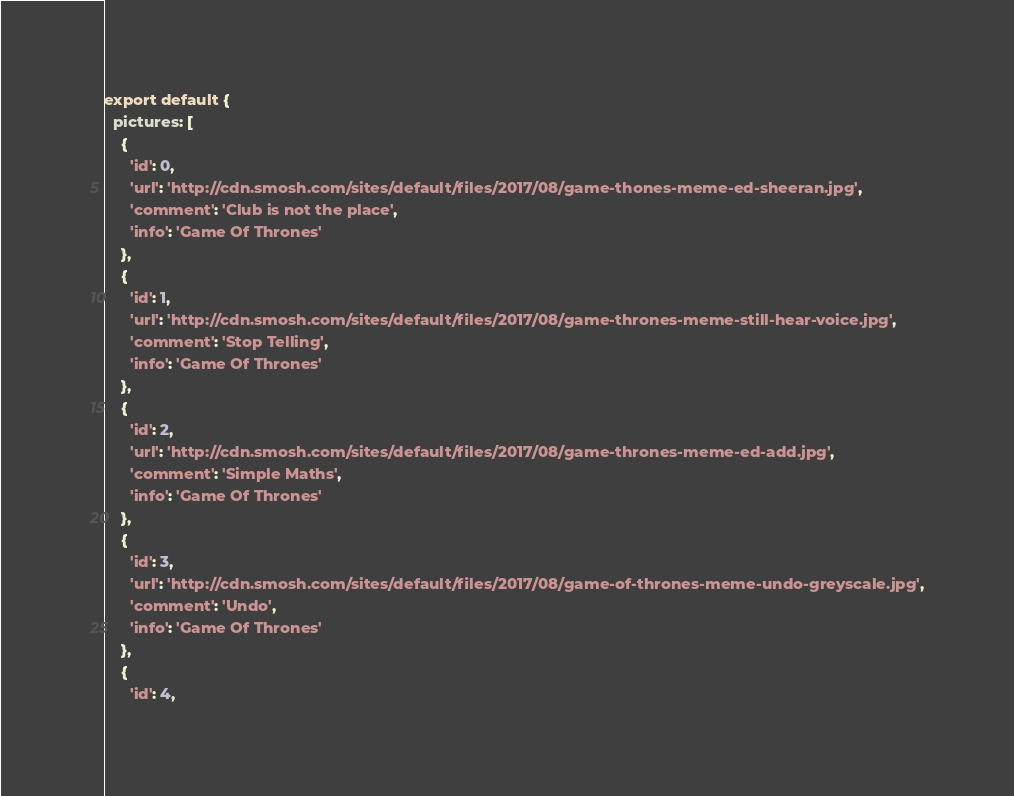<code> <loc_0><loc_0><loc_500><loc_500><_JavaScript_>export default {
  pictures: [
    {
      'id': 0,
      'url': 'http://cdn.smosh.com/sites/default/files/2017/08/game-thones-meme-ed-sheeran.jpg',
      'comment': 'Club is not the place',
      'info': 'Game Of Thrones'
    },
    {
      'id': 1,
      'url': 'http://cdn.smosh.com/sites/default/files/2017/08/game-thrones-meme-still-hear-voice.jpg',
      'comment': 'Stop Telling',
      'info': 'Game Of Thrones'
    },
    {
      'id': 2,
      'url': 'http://cdn.smosh.com/sites/default/files/2017/08/game-thrones-meme-ed-add.jpg',
      'comment': 'Simple Maths',
      'info': 'Game Of Thrones'
    },
    {
      'id': 3,
      'url': 'http://cdn.smosh.com/sites/default/files/2017/08/game-of-thrones-meme-undo-greyscale.jpg',
      'comment': 'Undo',
      'info': 'Game Of Thrones'
    },
    {
      'id': 4,</code> 